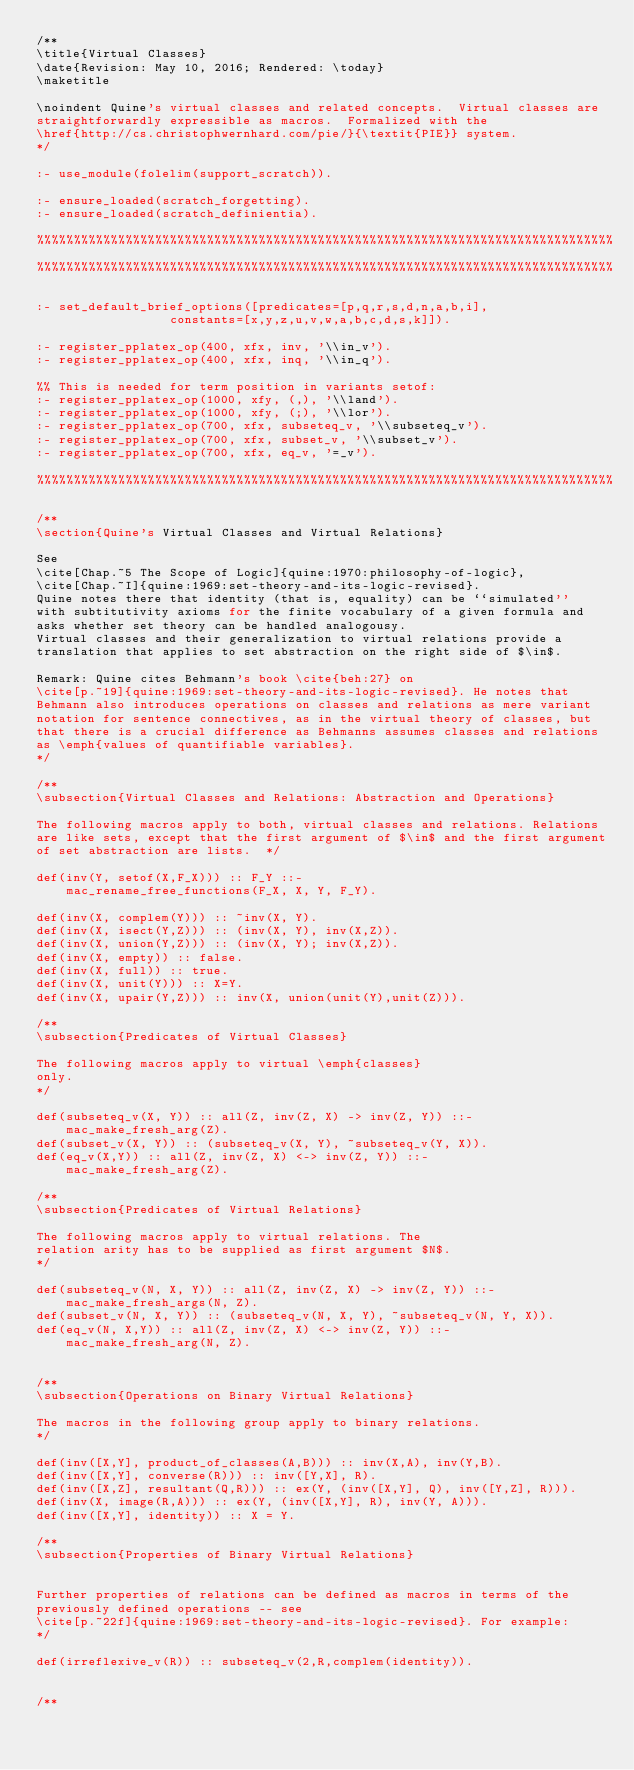<code> <loc_0><loc_0><loc_500><loc_500><_Perl_>/**
\title{Virtual Classes}
\date{Revision: May 10, 2016; Rendered: \today}  
\maketitle

\noindent Quine's virtual classes and related concepts.  Virtual classes are
straightforwardly expressible as macros.  Formalized with the
\href{http://cs.christophwernhard.com/pie/}{\textit{PIE}} system.
*/

:- use_module(folelim(support_scratch)).

:- ensure_loaded(scratch_forgetting).
:- ensure_loaded(scratch_definientia).

%%%%%%%%%%%%%%%%%%%%%%%%%%%%%%%%%%%%%%%%%%%%%%%%%%%%%%%%%%%%%%%%%%%%%%%%%%%%%%
%%%%%%%%%%%%%%%%%%%%%%%%%%%%%%%%%%%%%%%%%%%%%%%%%%%%%%%%%%%%%%%%%%%%%%%%%%%%%%

:- set_default_brief_options([predicates=[p,q,r,s,d,n,a,b,i],
			      constants=[x,y,z,u,v,w,a,b,c,d,s,k]]).

:- register_pplatex_op(400, xfx, inv, '\\in_v').
:- register_pplatex_op(400, xfx, inq, '\\in_q').

%% This is needed for term position in variants setof:
:- register_pplatex_op(1000, xfy, (,), '\\land').
:- register_pplatex_op(1000, xfy, (;), '\\lor').
:- register_pplatex_op(700, xfx, subseteq_v, '\\subseteq_v').
:- register_pplatex_op(700, xfx, subset_v, '\\subset_v').
:- register_pplatex_op(700, xfx, eq_v, '=_v').

%%%%%%%%%%%%%%%%%%%%%%%%%%%%%%%%%%%%%%%%%%%%%%%%%%%%%%%%%%%%%%%%%%%%%%%%%%%%%%

/**
\section{Quine's Virtual Classes and Virtual Relations}

See
\cite[Chap.~5 The Scope of Logic]{quine:1970:philosophy-of-logic},
\cite[Chap.~I]{quine:1969:set-theory-and-its-logic-revised}.
Quine notes there that identity (that is, equality) can be ``simulated''
with subtitutivity axioms for the finite vocabulary of a given formula and
asks whether set theory can be handled analogousy.
Virtual classes and their generalization to virtual relations provide a
translation that applies to set abstraction on the right side of $\in$.

Remark: Quine cites Behmann's book \cite{beh:27} on
\cite[p.~19]{quine:1969:set-theory-and-its-logic-revised}. He notes that
Behmann also introduces operations on classes and relations as mere variant
notation for sentence connectives, as in the virtual theory of classes, but
that there is a crucial difference as Behmanns assumes classes and relations
as \emph{values of quantifiable variables}.
*/

/**
\subsection{Virtual Classes and Relations: Abstraction and Operations}

The following macros apply to both, virtual classes and relations. Relations
are like sets, except that the first argument of $\in$ and the first argument
of set abstraction are lists.  */

def(inv(Y, setof(X,F_X))) :: F_Y ::-
	mac_rename_free_functions(F_X, X, Y, F_Y).

def(inv(X, complem(Y))) :: ~inv(X, Y).
def(inv(X, isect(Y,Z))) :: (inv(X, Y), inv(X,Z)).
def(inv(X, union(Y,Z))) :: (inv(X, Y); inv(X,Z)).
def(inv(X, empty)) :: false.
def(inv(X, full)) :: true.
def(inv(X, unit(Y))) :: X=Y.
def(inv(X, upair(Y,Z))) :: inv(X, union(unit(Y),unit(Z))).

/**
\subsection{Predicates of Virtual Classes}

The following macros apply to virtual \emph{classes}
only.
*/

def(subseteq_v(X, Y)) :: all(Z, inv(Z, X) -> inv(Z, Y)) ::-
	mac_make_fresh_arg(Z).
def(subset_v(X, Y)) :: (subseteq_v(X, Y), ~subseteq_v(Y, X)).
def(eq_v(X,Y)) :: all(Z, inv(Z, X) <-> inv(Z, Y)) ::- 
	mac_make_fresh_arg(Z).

/**
\subsection{Predicates of Virtual Relations}

The following macros apply to virtual relations. The
relation arity has to be supplied as first argument $N$.
*/

def(subseteq_v(N, X, Y)) :: all(Z, inv(Z, X) -> inv(Z, Y)) ::-
	mac_make_fresh_args(N, Z).
def(subset_v(N, X, Y)) :: (subseteq_v(N, X, Y), ~subseteq_v(N, Y, X)).
def(eq_v(N, X,Y)) :: all(Z, inv(Z, X) <-> inv(Z, Y)) ::- 
	mac_make_fresh_arg(N, Z).


/**
\subsection{Operations on Binary Virtual Relations}

The macros in the following group apply to binary relations.
*/

def(inv([X,Y], product_of_classes(A,B))) :: inv(X,A), inv(Y,B).
def(inv([X,Y], converse(R))) :: inv([Y,X], R).
def(inv([X,Z], resultant(Q,R))) :: ex(Y, (inv([X,Y], Q), inv([Y,Z], R))).
def(inv(X, image(R,A))) :: ex(Y, (inv([X,Y], R), inv(Y, A))).
def(inv([X,Y], identity)) :: X = Y.

/**
\subsection{Properties of Binary Virtual Relations}


Further properties of relations can be defined as macros in terms of the
previously defined operations -- see
\cite[p.~22f]{quine:1969:set-theory-and-its-logic-revised}. For example:
*/

def(irreflexive_v(R)) :: subseteq_v(2,R,complem(identity)).


/**</code> 